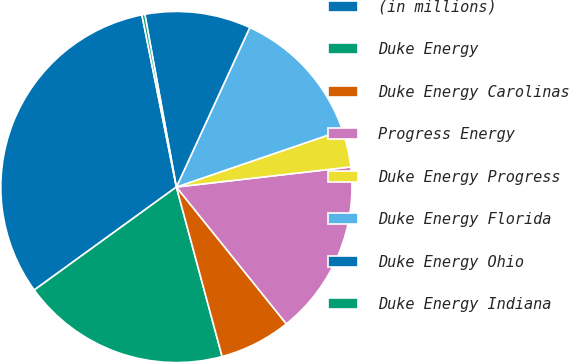Convert chart to OTSL. <chart><loc_0><loc_0><loc_500><loc_500><pie_chart><fcel>(in millions)<fcel>Duke Energy<fcel>Duke Energy Carolinas<fcel>Progress Energy<fcel>Duke Energy Progress<fcel>Duke Energy Florida<fcel>Duke Energy Ohio<fcel>Duke Energy Indiana<nl><fcel>31.83%<fcel>19.21%<fcel>6.58%<fcel>16.05%<fcel>3.42%<fcel>12.89%<fcel>9.74%<fcel>0.27%<nl></chart> 